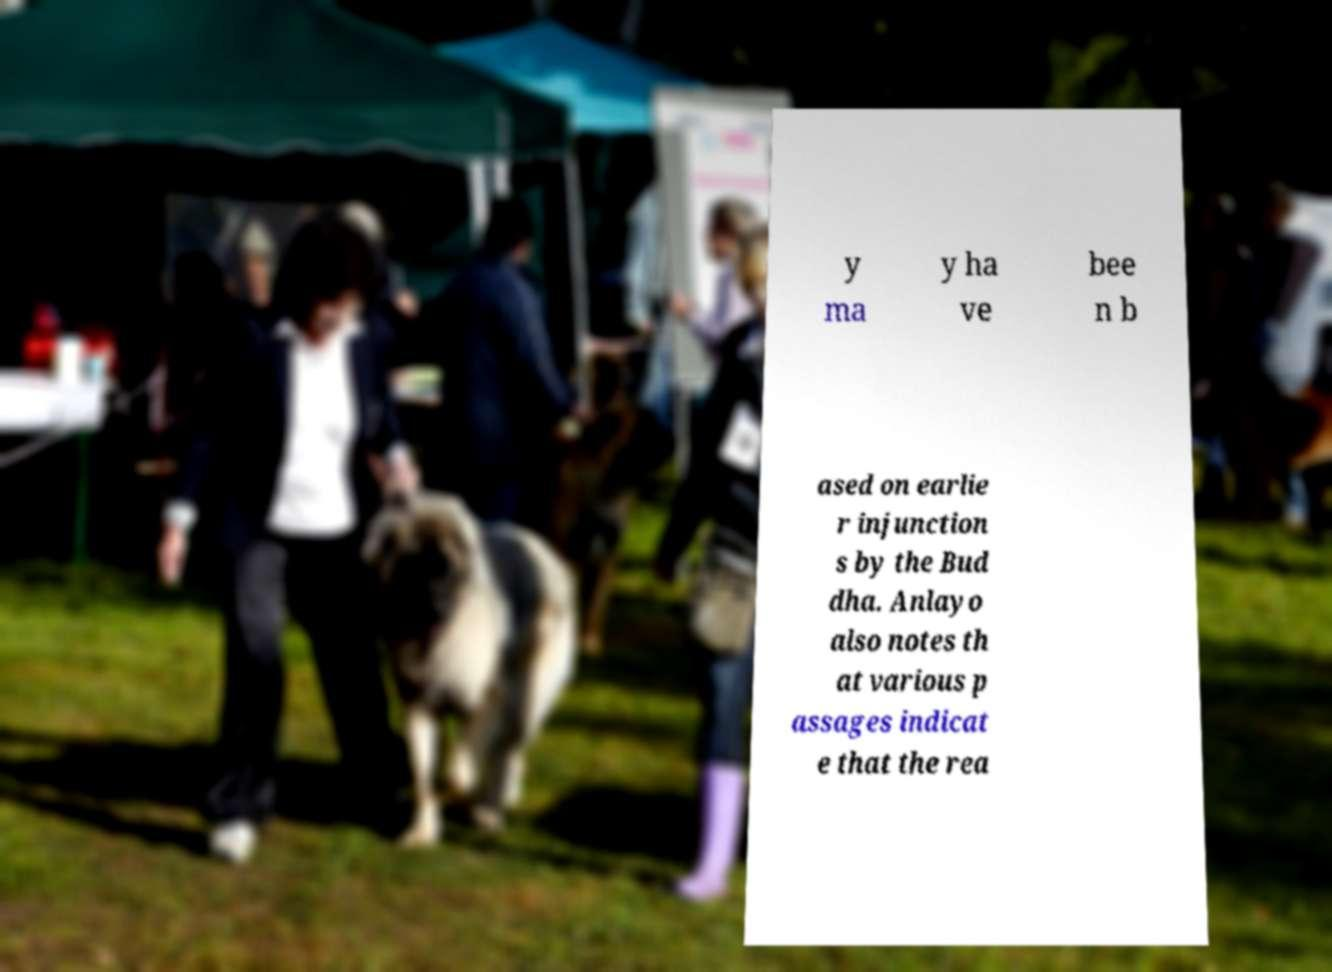Please read and relay the text visible in this image. What does it say? y ma y ha ve bee n b ased on earlie r injunction s by the Bud dha. Anlayo also notes th at various p assages indicat e that the rea 